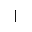<formula> <loc_0><loc_0><loc_500><loc_500>\lceil</formula> 